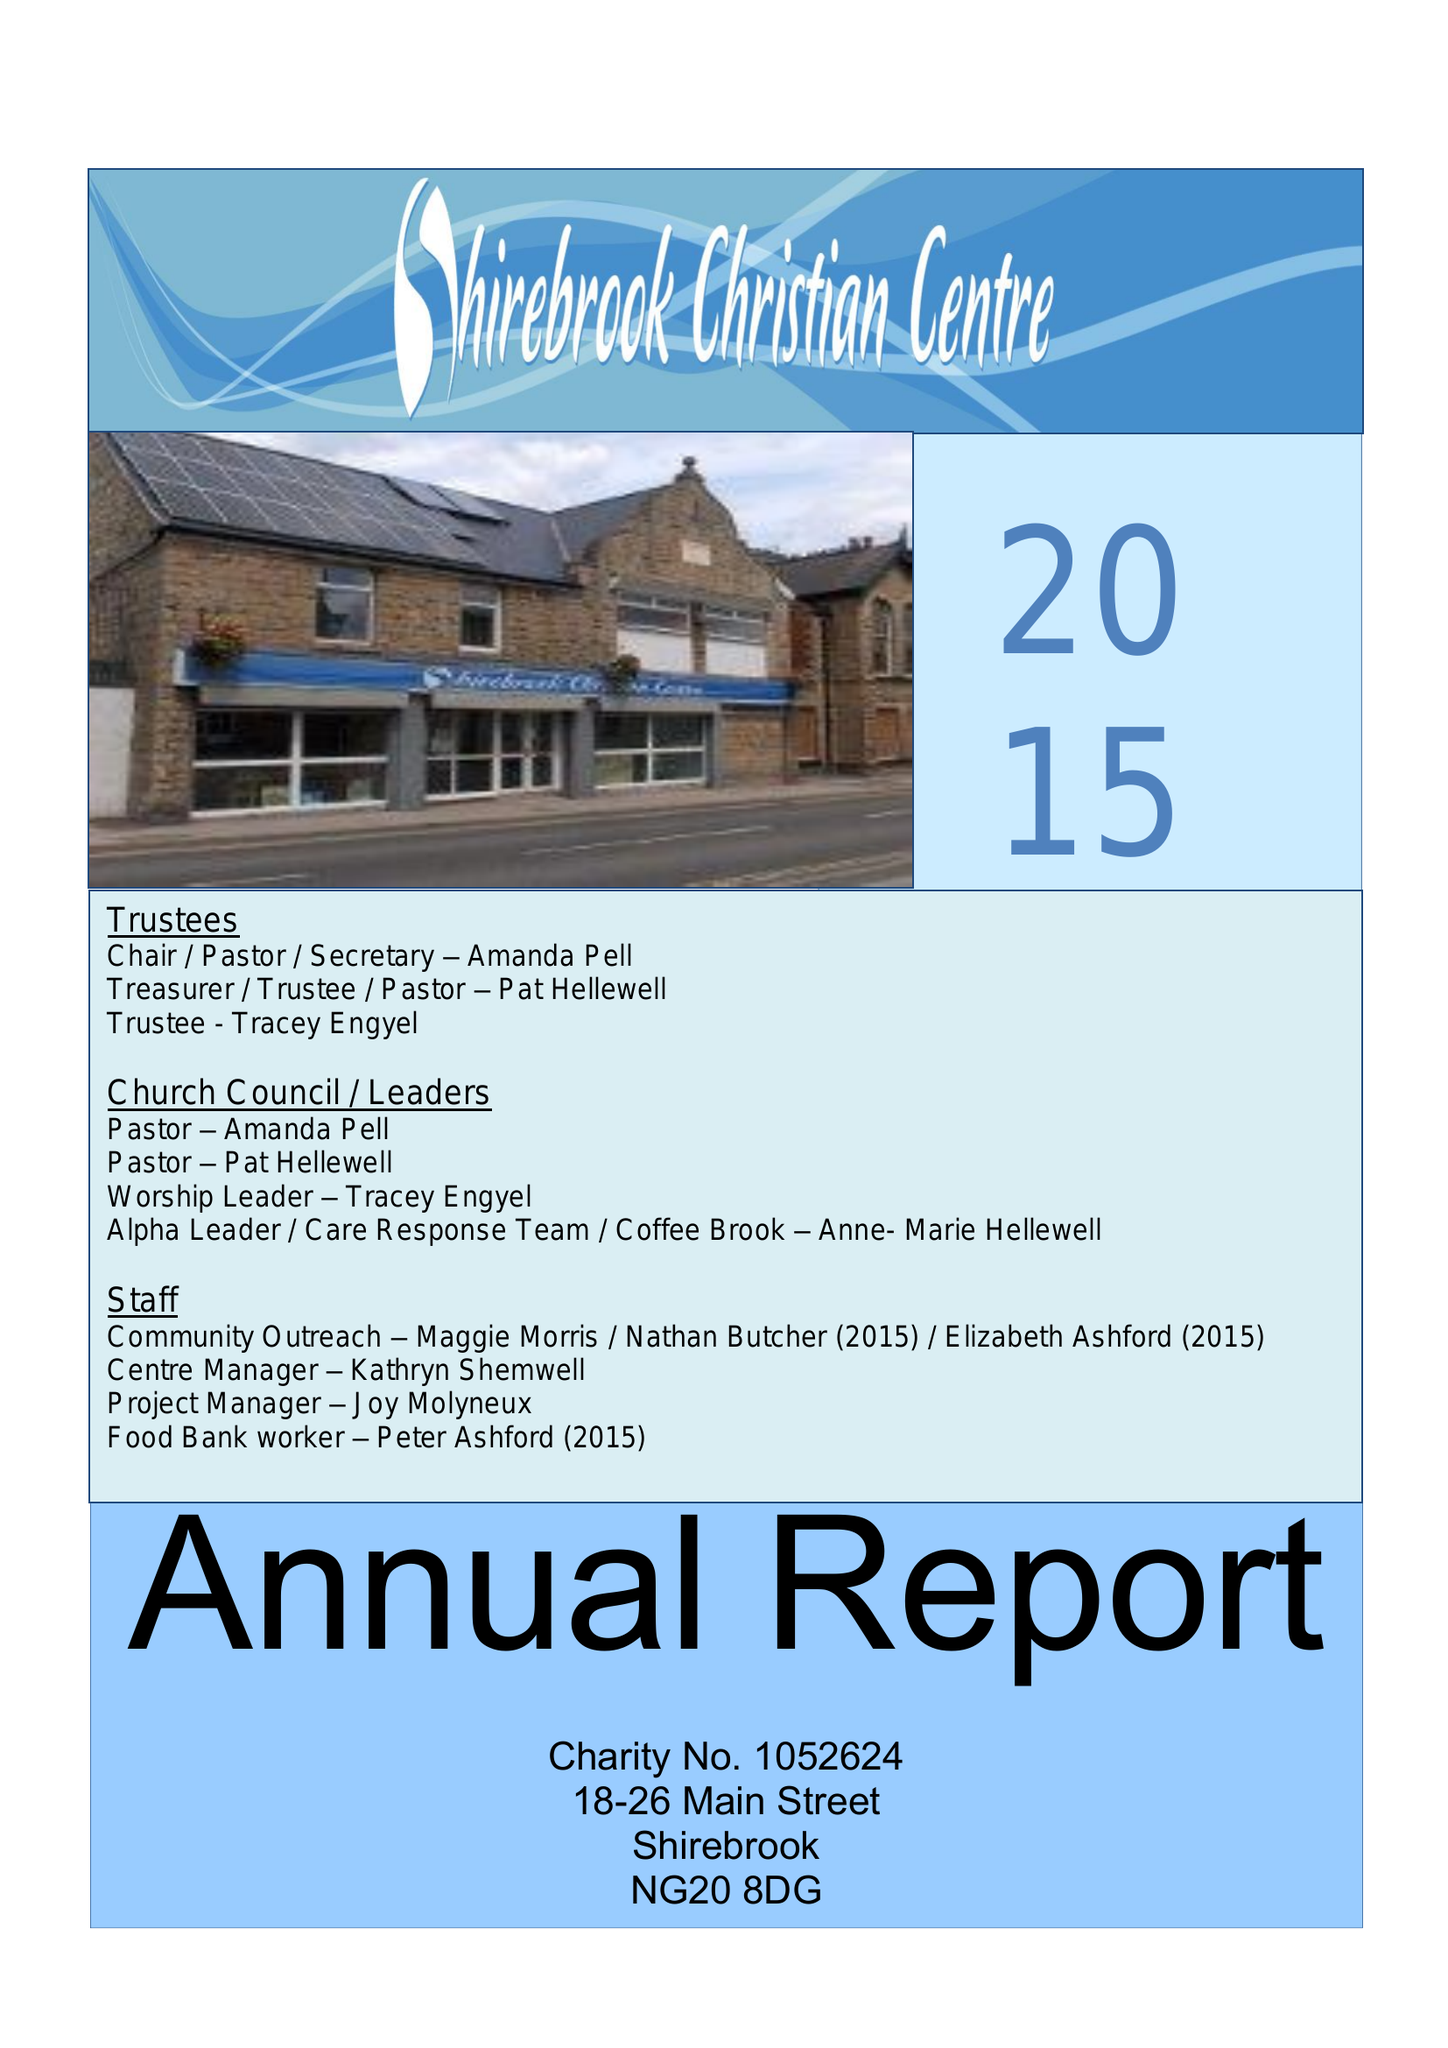What is the value for the income_annually_in_british_pounds?
Answer the question using a single word or phrase. 63648.00 